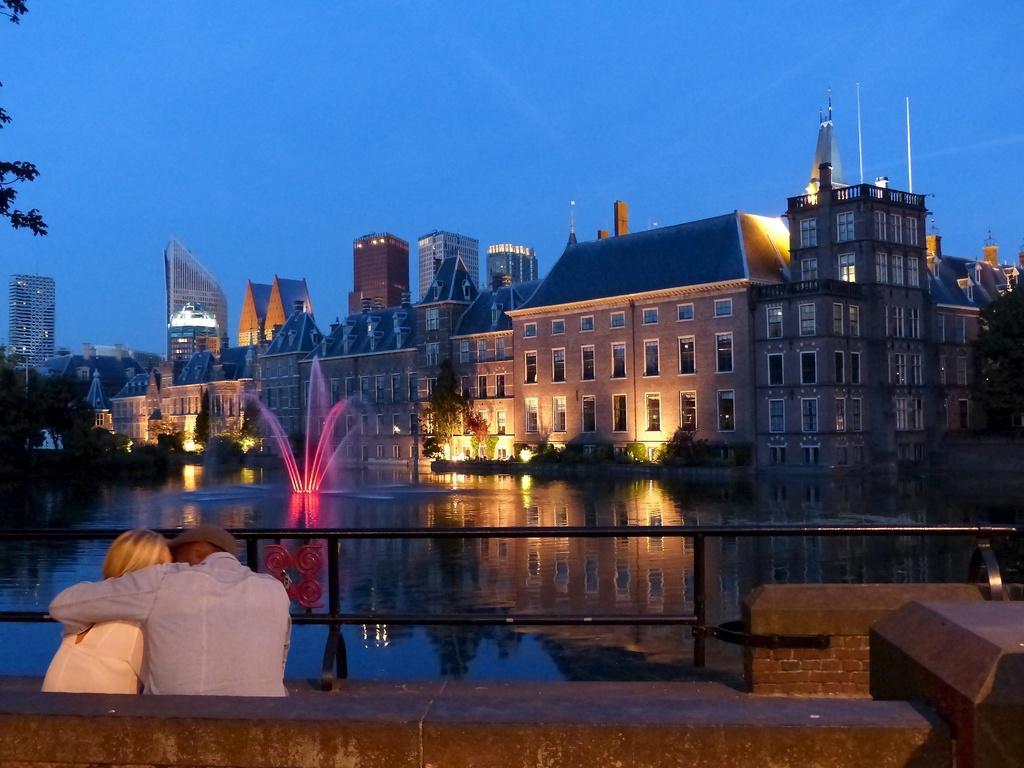Describe this image in one or two sentences. In this image we can see many buildings and they are having many windows. There is a lake in the image. There are few people in the image. There is a barrier in the image. We can see the reflection of lights and buildings on the water surface. There are many trees and plants in the image. We can see the sky in the image. 